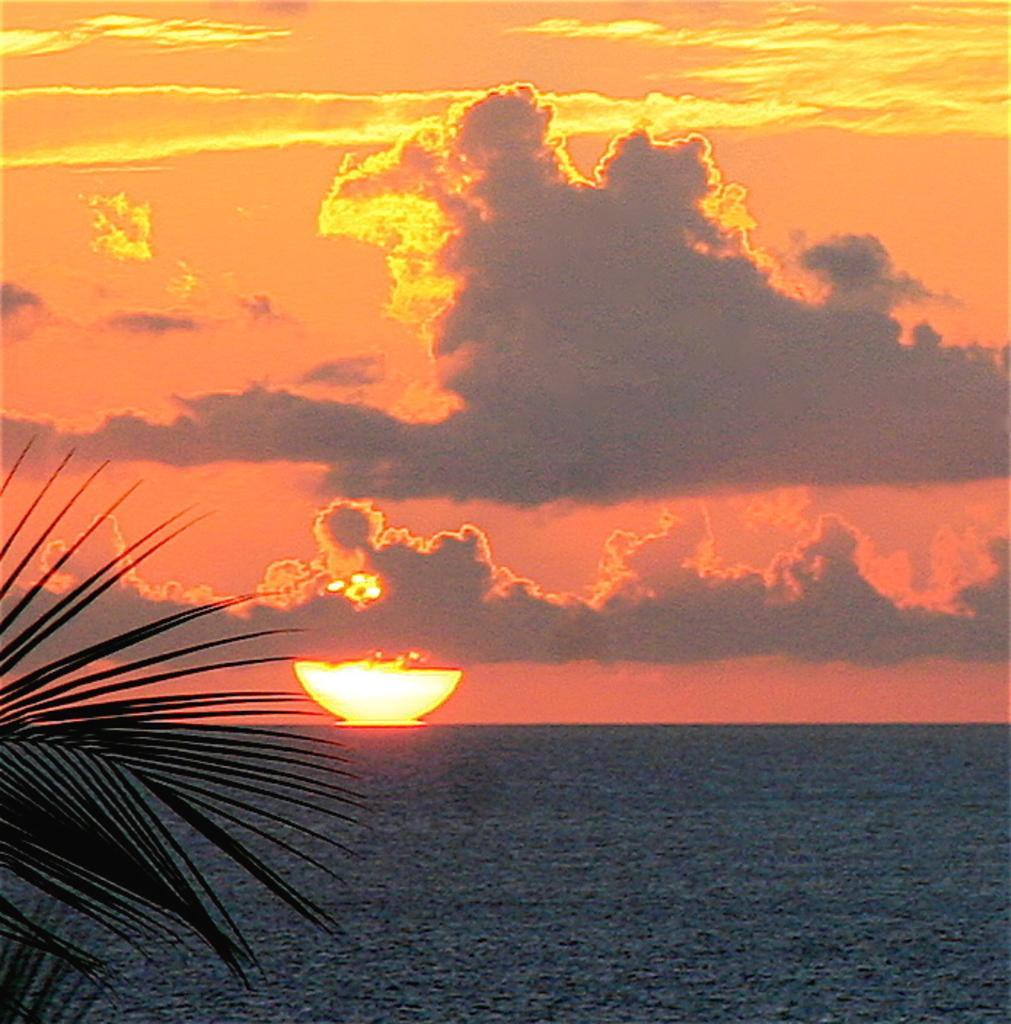In one or two sentences, can you explain what this image depicts? In this image there is a sun in middle of this image and there is a sunset at top of the image and there is a tree at left side of this image and there is a sea at bottom of this image. 